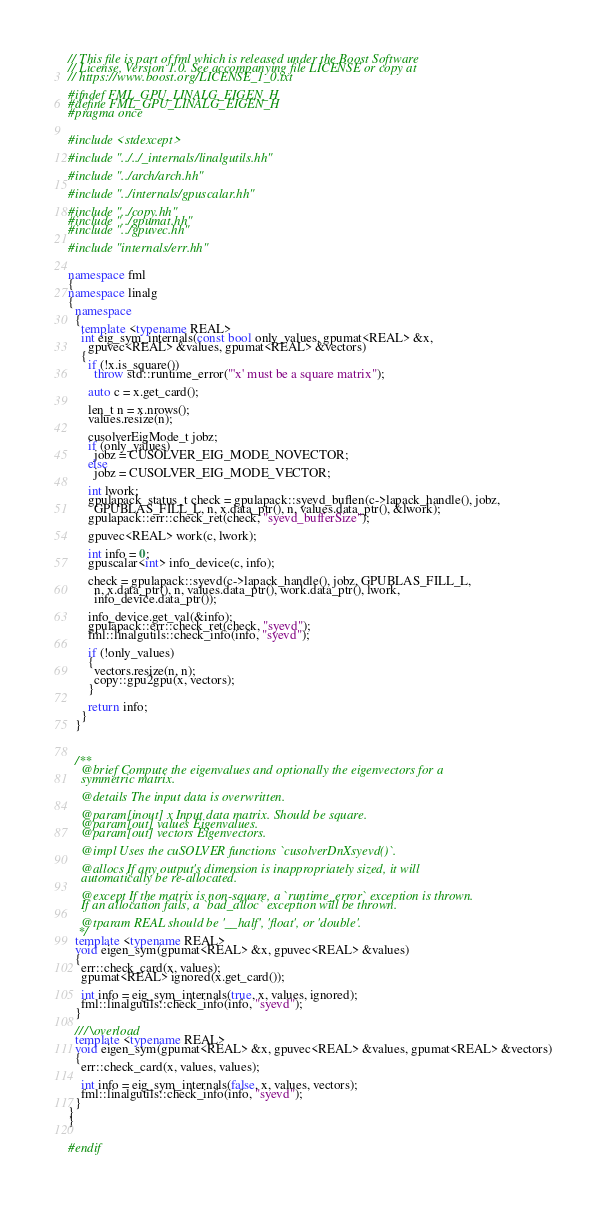Convert code to text. <code><loc_0><loc_0><loc_500><loc_500><_C++_>// This file is part of fml which is released under the Boost Software
// License, Version 1.0. See accompanying file LICENSE or copy at
// https://www.boost.org/LICENSE_1_0.txt

#ifndef FML_GPU_LINALG_EIGEN_H
#define FML_GPU_LINALG_EIGEN_H
#pragma once


#include <stdexcept>

#include "../../_internals/linalgutils.hh"

#include "../arch/arch.hh"

#include "../internals/gpuscalar.hh"

#include "../copy.hh"
#include "../gpumat.hh"
#include "../gpuvec.hh"

#include "internals/err.hh"


namespace fml
{
namespace linalg
{
  namespace
  {
    template <typename REAL>
    int eig_sym_internals(const bool only_values, gpumat<REAL> &x,
      gpuvec<REAL> &values, gpumat<REAL> &vectors)
    {
      if (!x.is_square())
        throw std::runtime_error("'x' must be a square matrix");
      
      auto c = x.get_card();
      
      len_t n = x.nrows();
      values.resize(n);
      
      cusolverEigMode_t jobz;
      if (only_values)
        jobz = CUSOLVER_EIG_MODE_NOVECTOR;
      else
        jobz = CUSOLVER_EIG_MODE_VECTOR;
      
      int lwork;
      gpulapack_status_t check = gpulapack::syevd_buflen(c->lapack_handle(), jobz,
        GPUBLAS_FILL_L, n, x.data_ptr(), n, values.data_ptr(), &lwork);
      gpulapack::err::check_ret(check, "syevd_bufferSize");
      
      gpuvec<REAL> work(c, lwork);
      
      int info = 0;
      gpuscalar<int> info_device(c, info);
      
      check = gpulapack::syevd(c->lapack_handle(), jobz, GPUBLAS_FILL_L,
        n, x.data_ptr(), n, values.data_ptr(), work.data_ptr(), lwork,
        info_device.data_ptr());
      
      info_device.get_val(&info);
      gpulapack::err::check_ret(check, "syevd");
      fml::linalgutils::check_info(info, "syevd");
      
      if (!only_values)
      {
        vectors.resize(n, n);
        copy::gpu2gpu(x, vectors);
      }
      
      return info;
    }
  }
  
  
  
  /**
    @brief Compute the eigenvalues and optionally the eigenvectors for a
    symmetric matrix.
    
    @details The input data is overwritten.
    
    @param[inout] x Input data matrix. Should be square.
    @param[out] values Eigenvalues.
    @param[out] vectors Eigenvectors.
    
    @impl Uses the cuSOLVER functions `cusolverDnXsyevd()`.
    
    @allocs If any output's dimension is inappropriately sized, it will
    automatically be re-allocated.
    
    @except If the matrix is non-square, a `runtime_error` exception is thrown.
    If an allocation fails, a `bad_alloc` exception will be thrown.
    
    @tparam REAL should be '__half', 'float', or 'double'.
   */
  template <typename REAL>
  void eigen_sym(gpumat<REAL> &x, gpuvec<REAL> &values)
  {
    err::check_card(x, values);
    gpumat<REAL> ignored(x.get_card());
    
    int info = eig_sym_internals(true, x, values, ignored);
    fml::linalgutils::check_info(info, "syevd");
  }
  
  /// \overload
  template <typename REAL>
  void eigen_sym(gpumat<REAL> &x, gpuvec<REAL> &values, gpumat<REAL> &vectors)
  {
    err::check_card(x, values, values);
    
    int info = eig_sym_internals(false, x, values, vectors);
    fml::linalgutils::check_info(info, "syevd");
  }
}
}


#endif
</code> 